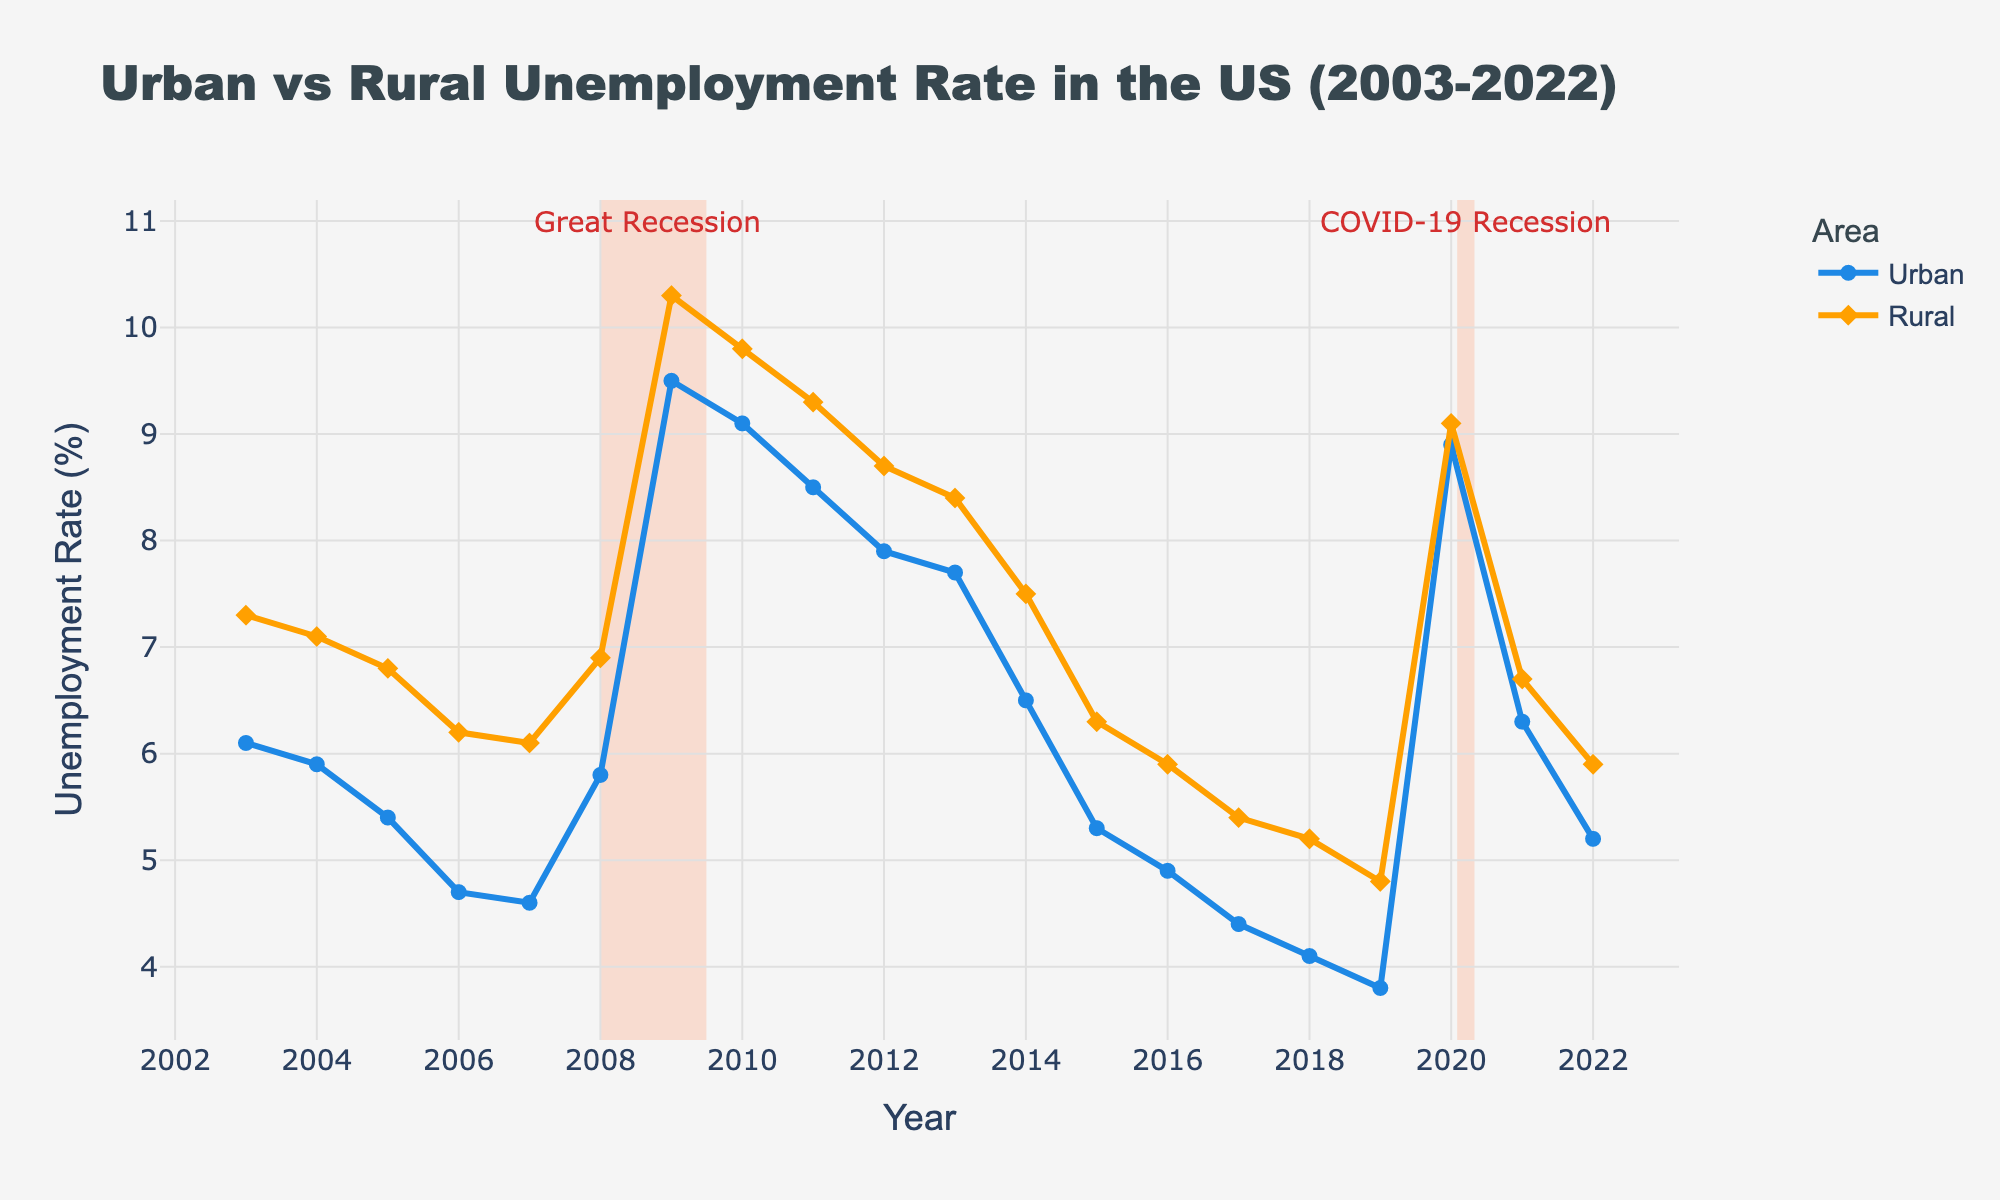What's the title of the plot? The title of the plot can be found at the top of the figure. It reads "Urban vs Rural Unemployment Rate in the US (2003-2022)".
Answer: Urban vs Rural Unemployment Rate in the US (2003-2022) What are the colors representing the urban and rural unemployment rates? The urban unemployment rate is represented in blue, while the rural unemployment rate is represented in orange, as indicated by the lines and legend.
Answer: Blue is urban, Orange is rural How many recession periods are highlighted in the plot? There are two recession periods highlighted by light salmon vertical rectangles: one around 2008-2009 and one in 2020.
Answer: Two During which years did the urban unemployment rate peak? The urban unemployment rate peaked in 2009 as indicated by the highest point on the blue line.
Answer: 2009 What was the rural unemployment rate in 2009? Looking at the diamond marker on the orange line for the year 2009, the rural unemployment rate was 10.3%.
Answer: 10.3% By how much did the urban unemployment rate change from 2008 to 2009? The urban unemployment rate in 2008 was 5.8%, and it increased to 9.5% in 2009. The change is calculated as 9.5 - 5.8.
Answer: 3.7% Which area had a higher unemployment rate during the Great Recession, and by how much? During the Great Recession in 2009, the urban rate was 9.5%, and the rural rate was 10.3%. The rural rate was higher by 10.3 - 9.5.
Answer: Rural by 0.8% Is there any period where the rural unemployment rate dropped below the urban unemployment rate? By inspecting the plot, we see no period where the rural unemployment rate (orange line) drops below the urban unemployment rate (blue line).
Answer: No What was the trend in urban unemployment rates from 2015 to 2019? The urban unemployment rate showed a decreasing trend from 2015 (5.3%) to 2019 (3.8%), indicating a consistent drop over these years.
Answer: Decreasing During the COVID-19 recession, what was the rural unemployment rate? The rural unemployment rate during the COVID-19 recession spike in 2020, as marked by the annotation, was 9.1%.
Answer: 9.1% 